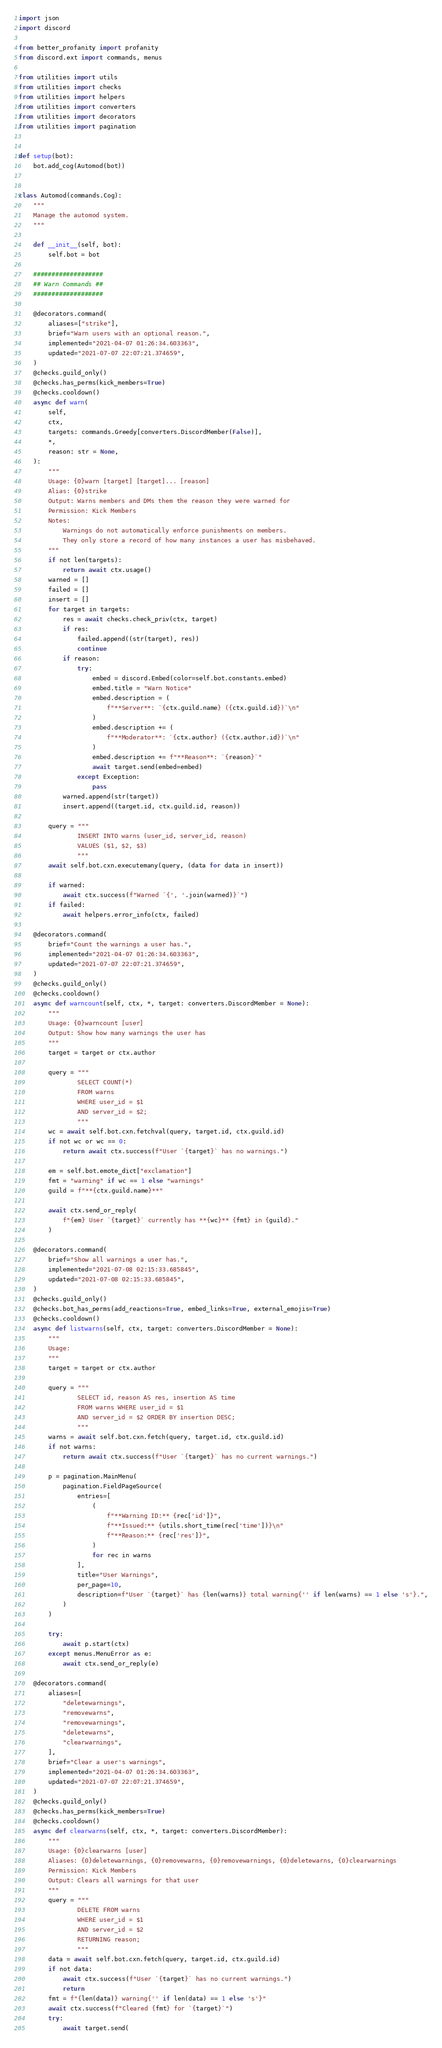Convert code to text. <code><loc_0><loc_0><loc_500><loc_500><_Python_>import json
import discord

from better_profanity import profanity
from discord.ext import commands, menus

from utilities import utils
from utilities import checks
from utilities import helpers
from utilities import converters
from utilities import decorators
from utilities import pagination


def setup(bot):
    bot.add_cog(Automod(bot))


class Automod(commands.Cog):
    """
    Manage the automod system.
    """

    def __init__(self, bot):
        self.bot = bot

    ###################
    ## Warn Commands ##
    ###################

    @decorators.command(
        aliases=["strike"],
        brief="Warn users with an optional reason.",
        implemented="2021-04-07 01:26:34.603363",
        updated="2021-07-07 22:07:21.374659",
    )
    @checks.guild_only()
    @checks.has_perms(kick_members=True)
    @checks.cooldown()
    async def warn(
        self,
        ctx,
        targets: commands.Greedy[converters.DiscordMember(False)],
        *,
        reason: str = None,
    ):
        """
        Usage: {0}warn [target] [target]... [reason]
        Alias: {0}strike
        Output: Warns members and DMs them the reason they were warned for
        Permission: Kick Members
        Notes:
            Warnings do not automatically enforce punishments on members.
            They only store a record of how many instances a user has misbehaved.
        """
        if not len(targets):
            return await ctx.usage()
        warned = []
        failed = []
        insert = []
        for target in targets:
            res = await checks.check_priv(ctx, target)
            if res:
                failed.append((str(target), res))
                continue
            if reason:
                try:
                    embed = discord.Embed(color=self.bot.constants.embed)
                    embed.title = "Warn Notice"
                    embed.description = (
                        f"**Server**: `{ctx.guild.name} ({ctx.guild.id})`\n"
                    )
                    embed.description += (
                        f"**Moderator**: `{ctx.author} ({ctx.author.id})`\n"
                    )
                    embed.description += f"**Reason**: `{reason}`"
                    await target.send(embed=embed)
                except Exception:
                    pass
            warned.append(str(target))
            insert.append((target.id, ctx.guild.id, reason))

        query = """
                INSERT INTO warns (user_id, server_id, reason)
                VALUES ($1, $2, $3)
                """
        await self.bot.cxn.executemany(query, (data for data in insert))

        if warned:
            await ctx.success(f"Warned `{', '.join(warned)}`")
        if failed:
            await helpers.error_info(ctx, failed)

    @decorators.command(
        brief="Count the warnings a user has.",
        implemented="2021-04-07 01:26:34.603363",
        updated="2021-07-07 22:07:21.374659",
    )
    @checks.guild_only()
    @checks.cooldown()
    async def warncount(self, ctx, *, target: converters.DiscordMember = None):
        """
        Usage: {0}warncount [user]
        Output: Show how many warnings the user has
        """
        target = target or ctx.author

        query = """
                SELECT COUNT(*)
                FROM warns
                WHERE user_id = $1
                AND server_id = $2;
                """
        wc = await self.bot.cxn.fetchval(query, target.id, ctx.guild.id)
        if not wc or wc == 0:
            return await ctx.success(f"User `{target}` has no warnings.")

        em = self.bot.emote_dict["exclamation"]
        fmt = "warning" if wc == 1 else "warnings"
        guild = f"**{ctx.guild.name}**"

        await ctx.send_or_reply(
            f"{em} User `{target}` currently has **{wc}** {fmt} in {guild}."
        )

    @decorators.command(
        brief="Show all warnings a user has.",
        implemented="2021-07-08 02:15:33.685845",
        updated="2021-07-08 02:15:33.685845",
    )
    @checks.guild_only()
    @checks.bot_has_perms(add_reactions=True, embed_links=True, external_emojis=True)
    @checks.cooldown()
    async def listwarns(self, ctx, target: converters.DiscordMember = None):
        """
        Usage:
        """
        target = target or ctx.author

        query = """
                SELECT id, reason AS res, insertion AS time
                FROM warns WHERE user_id = $1
                AND server_id = $2 ORDER BY insertion DESC;
                """
        warns = await self.bot.cxn.fetch(query, target.id, ctx.guild.id)
        if not warns:
            return await ctx.success(f"User `{target}` has no current warnings.")

        p = pagination.MainMenu(
            pagination.FieldPageSource(
                entries=[
                    (
                        f"**Warning ID:** {rec['id']}",
                        f"**Issued:** {utils.short_time(rec['time'])}\n"
                        f"**Reason:** {rec['res']}",
                    )
                    for rec in warns
                ],
                title="User Warnings",
                per_page=10,
                description=f"User `{target}` has {len(warns)} total warning{'' if len(warns) == 1 else 's'}.",
            )
        )

        try:
            await p.start(ctx)
        except menus.MenuError as e:
            await ctx.send_or_reply(e)

    @decorators.command(
        aliases=[
            "deletewarnings",
            "removewarns",
            "removewarnings",
            "deletewarns",
            "clearwarnings",
        ],
        brief="Clear a user's warnings",
        implemented="2021-04-07 01:26:34.603363",
        updated="2021-07-07 22:07:21.374659",
    )
    @checks.guild_only()
    @checks.has_perms(kick_members=True)
    @checks.cooldown()
    async def clearwarns(self, ctx, *, target: converters.DiscordMember):
        """
        Usage: {0}clearwarns [user]
        Aliases: {0}deletewarnings, {0}removewarns, {0}removewarnings, {0}deletewarns, {0}clearwarnings
        Permission: Kick Members
        Output: Clears all warnings for that user
        """
        query = """
                DELETE FROM warns
                WHERE user_id = $1
                AND server_id = $2
                RETURNING reason;
                """
        data = await self.bot.cxn.fetch(query, target.id, ctx.guild.id)
        if not data:
            await ctx.success(f"User `{target}` has no current warnings.")
            return
        fmt = f"{len(data)} warning{'' if len(data) == 1 else 's'}"
        await ctx.success(f"Cleared {fmt} for `{target}`")
        try:
            await target.send(</code> 